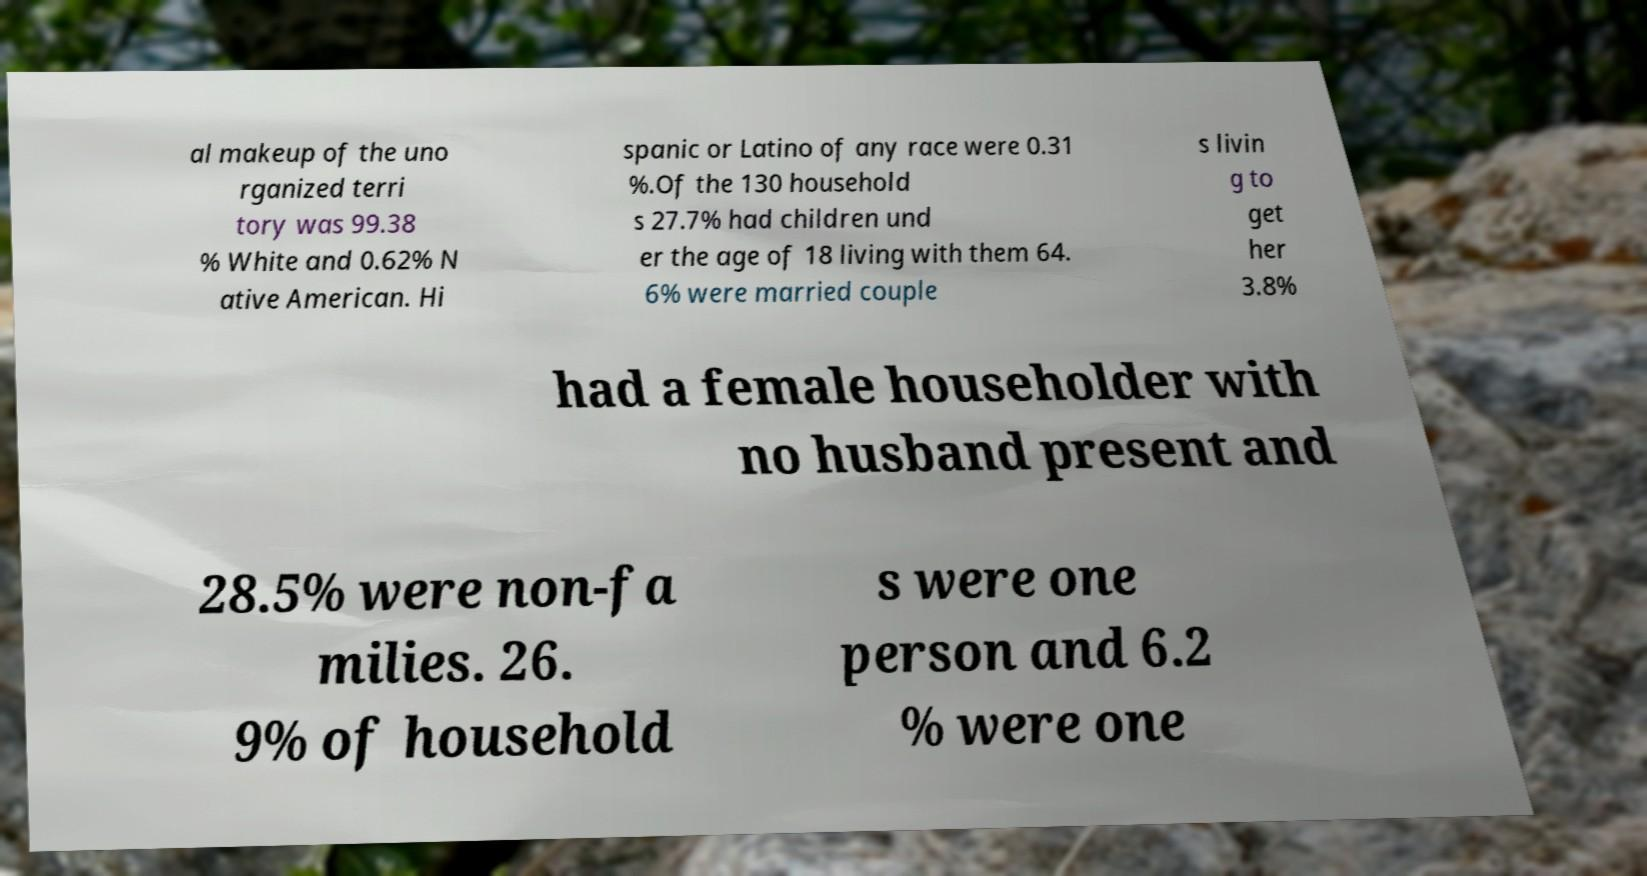Please read and relay the text visible in this image. What does it say? al makeup of the uno rganized terri tory was 99.38 % White and 0.62% N ative American. Hi spanic or Latino of any race were 0.31 %.Of the 130 household s 27.7% had children und er the age of 18 living with them 64. 6% were married couple s livin g to get her 3.8% had a female householder with no husband present and 28.5% were non-fa milies. 26. 9% of household s were one person and 6.2 % were one 